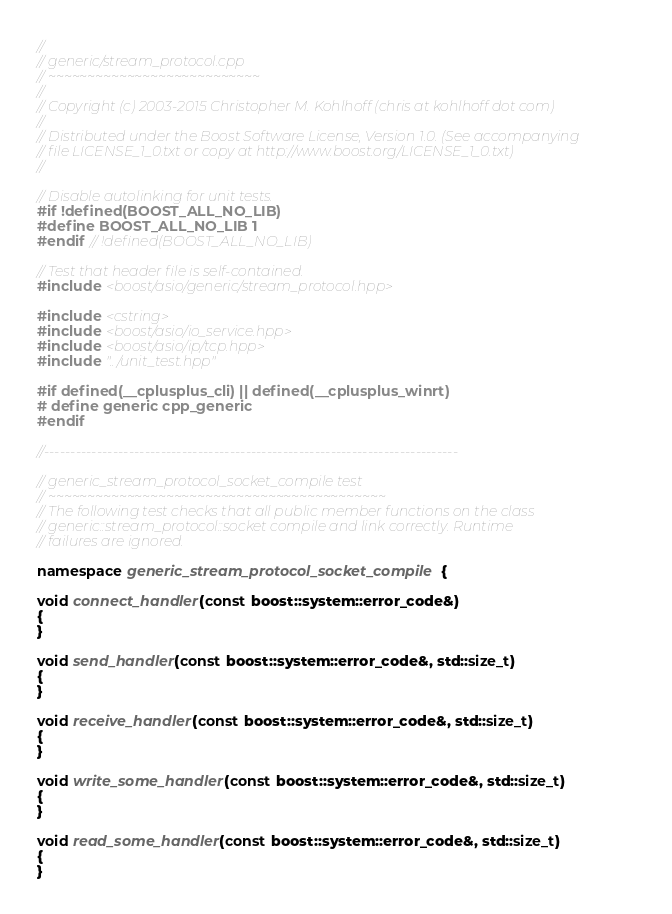Convert code to text. <code><loc_0><loc_0><loc_500><loc_500><_C++_>//
// generic/stream_protocol.cpp
// ~~~~~~~~~~~~~~~~~~~~~~~~~~~
//
// Copyright (c) 2003-2015 Christopher M. Kohlhoff (chris at kohlhoff dot com)
//
// Distributed under the Boost Software License, Version 1.0. (See accompanying
// file LICENSE_1_0.txt or copy at http://www.boost.org/LICENSE_1_0.txt)
//

// Disable autolinking for unit tests.
#if !defined(BOOST_ALL_NO_LIB)
#define BOOST_ALL_NO_LIB 1
#endif // !defined(BOOST_ALL_NO_LIB)

// Test that header file is self-contained.
#include <boost/asio/generic/stream_protocol.hpp>

#include <cstring>
#include <boost/asio/io_service.hpp>
#include <boost/asio/ip/tcp.hpp>
#include "../unit_test.hpp"

#if defined(__cplusplus_cli) || defined(__cplusplus_winrt)
# define generic cpp_generic
#endif

//------------------------------------------------------------------------------

// generic_stream_protocol_socket_compile test
// ~~~~~~~~~~~~~~~~~~~~~~~~~~~~~~~~~~~~~~~~~~~
// The following test checks that all public member functions on the class
// generic::stream_protocol::socket compile and link correctly. Runtime
// failures are ignored.

namespace generic_stream_protocol_socket_compile {

void connect_handler(const boost::system::error_code&)
{
}

void send_handler(const boost::system::error_code&, std::size_t)
{
}

void receive_handler(const boost::system::error_code&, std::size_t)
{
}

void write_some_handler(const boost::system::error_code&, std::size_t)
{
}

void read_some_handler(const boost::system::error_code&, std::size_t)
{
}
</code> 